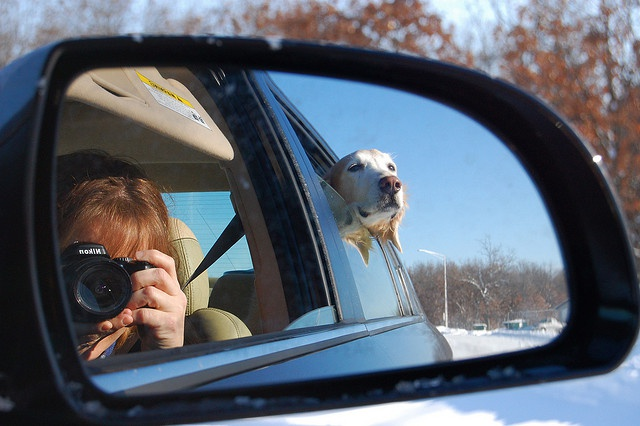Describe the objects in this image and their specific colors. I can see car in darkgray, black, gray, and lightblue tones, people in darkgray, black, maroon, and brown tones, and dog in darkgray, gray, white, and black tones in this image. 